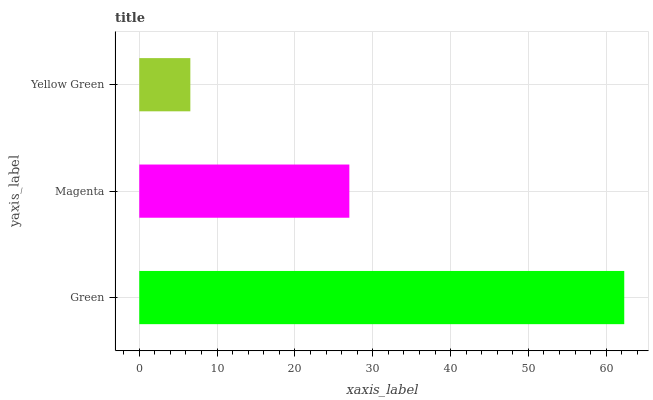Is Yellow Green the minimum?
Answer yes or no. Yes. Is Green the maximum?
Answer yes or no. Yes. Is Magenta the minimum?
Answer yes or no. No. Is Magenta the maximum?
Answer yes or no. No. Is Green greater than Magenta?
Answer yes or no. Yes. Is Magenta less than Green?
Answer yes or no. Yes. Is Magenta greater than Green?
Answer yes or no. No. Is Green less than Magenta?
Answer yes or no. No. Is Magenta the high median?
Answer yes or no. Yes. Is Magenta the low median?
Answer yes or no. Yes. Is Yellow Green the high median?
Answer yes or no. No. Is Yellow Green the low median?
Answer yes or no. No. 